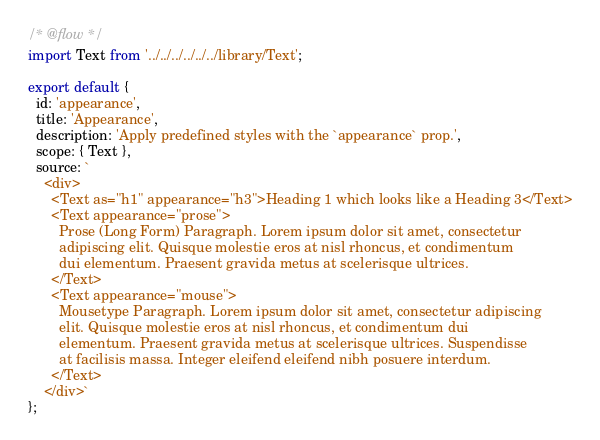Convert code to text. <code><loc_0><loc_0><loc_500><loc_500><_JavaScript_>/* @flow */
import Text from '../../../../../../library/Text';

export default {
  id: 'appearance',
  title: 'Appearance',
  description: 'Apply predefined styles with the `appearance` prop.',
  scope: { Text },
  source: `
    <div>
      <Text as="h1" appearance="h3">Heading 1 which looks like a Heading 3</Text>
      <Text appearance="prose">
        Prose (Long Form) Paragraph. Lorem ipsum dolor sit amet, consectetur
        adipiscing elit. Quisque molestie eros at nisl rhoncus, et condimentum
        dui elementum. Praesent gravida metus at scelerisque ultrices.
      </Text>
      <Text appearance="mouse">
        Mousetype Paragraph. Lorem ipsum dolor sit amet, consectetur adipiscing
        elit. Quisque molestie eros at nisl rhoncus, et condimentum dui
        elementum. Praesent gravida metus at scelerisque ultrices. Suspendisse
        at facilisis massa. Integer eleifend eleifend nibh posuere interdum.
      </Text>
    </div>`
};
</code> 